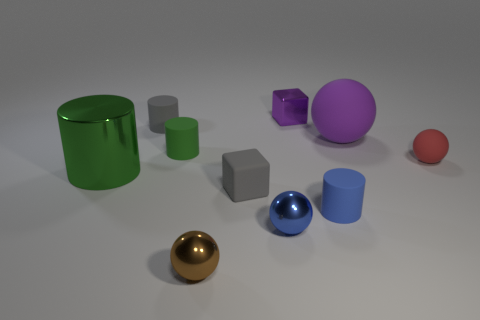Subtract 1 cylinders. How many cylinders are left? 3 Subtract all cyan blocks. Subtract all cyan balls. How many blocks are left? 2 Subtract all cubes. How many objects are left? 8 Subtract 1 green cylinders. How many objects are left? 9 Subtract all big blue cubes. Subtract all large green shiny cylinders. How many objects are left? 9 Add 9 big rubber balls. How many big rubber balls are left? 10 Add 3 tiny green metal spheres. How many tiny green metal spheres exist? 3 